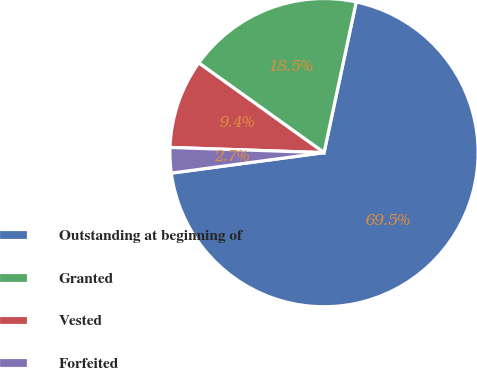Convert chart. <chart><loc_0><loc_0><loc_500><loc_500><pie_chart><fcel>Outstanding at beginning of<fcel>Granted<fcel>Vested<fcel>Forfeited<nl><fcel>69.53%<fcel>18.46%<fcel>9.35%<fcel>2.66%<nl></chart> 